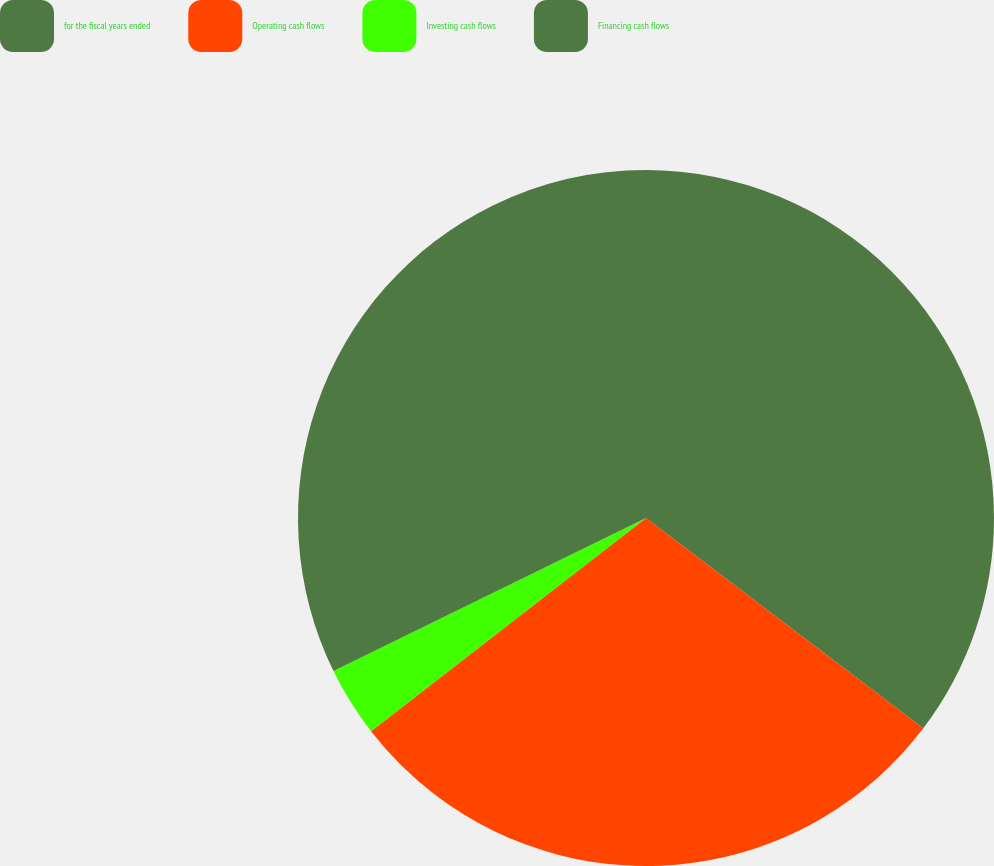<chart> <loc_0><loc_0><loc_500><loc_500><pie_chart><fcel>for the fiscal years ended<fcel>Operating cash flows<fcel>Investing cash flows<fcel>Financing cash flows<nl><fcel>35.33%<fcel>29.17%<fcel>3.25%<fcel>32.25%<nl></chart> 